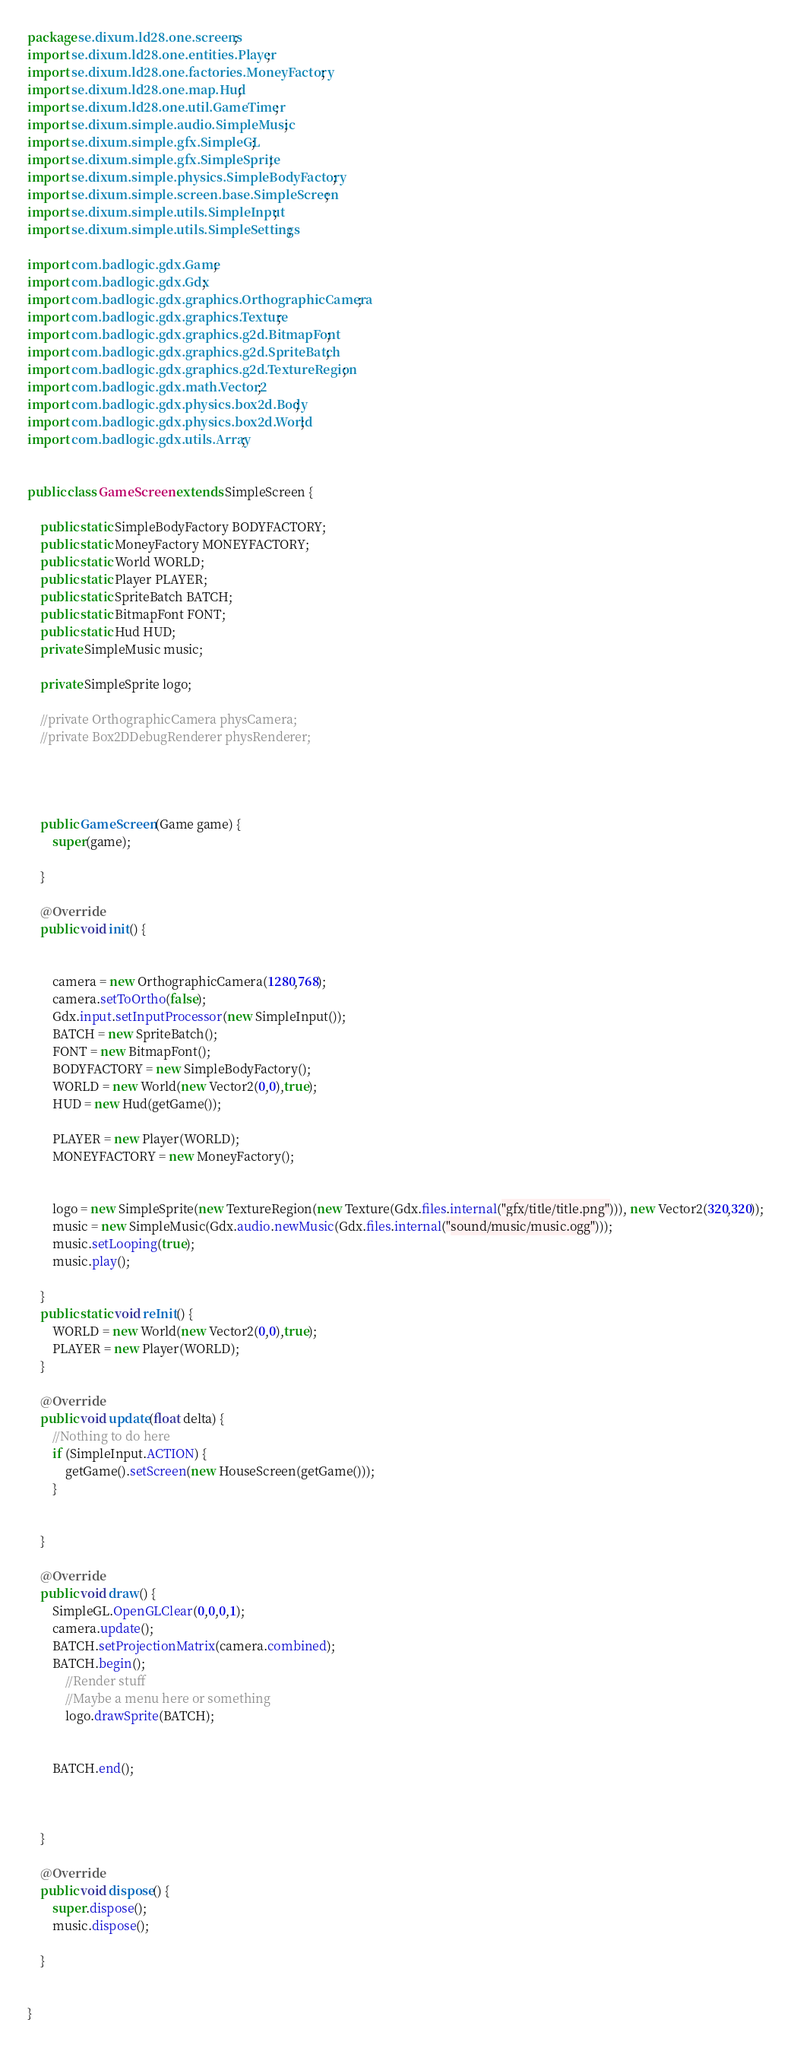Convert code to text. <code><loc_0><loc_0><loc_500><loc_500><_Java_>package se.dixum.ld28.one.screens;
import se.dixum.ld28.one.entities.Player;
import se.dixum.ld28.one.factories.MoneyFactory;
import se.dixum.ld28.one.map.Hud;
import se.dixum.ld28.one.util.GameTimer;
import se.dixum.simple.audio.SimpleMusic;
import se.dixum.simple.gfx.SimpleGL;
import se.dixum.simple.gfx.SimpleSprite;
import se.dixum.simple.physics.SimpleBodyFactory;
import se.dixum.simple.screen.base.SimpleScreen;
import se.dixum.simple.utils.SimpleInput;
import se.dixum.simple.utils.SimpleSettings;

import com.badlogic.gdx.Game;
import com.badlogic.gdx.Gdx;
import com.badlogic.gdx.graphics.OrthographicCamera;
import com.badlogic.gdx.graphics.Texture;
import com.badlogic.gdx.graphics.g2d.BitmapFont;
import com.badlogic.gdx.graphics.g2d.SpriteBatch;
import com.badlogic.gdx.graphics.g2d.TextureRegion;
import com.badlogic.gdx.math.Vector2;
import com.badlogic.gdx.physics.box2d.Body;
import com.badlogic.gdx.physics.box2d.World;
import com.badlogic.gdx.utils.Array;


public class GameScreen extends SimpleScreen {
	
	public static SimpleBodyFactory BODYFACTORY;
	public static MoneyFactory MONEYFACTORY;
	public static World WORLD;
	public static Player PLAYER;
	public static SpriteBatch BATCH;
	public static BitmapFont FONT;
	public static Hud HUD; 
	private SimpleMusic music;
	
	private SimpleSprite logo;
	
	//private OrthographicCamera physCamera;
	//private Box2DDebugRenderer physRenderer;



	
	public GameScreen(Game game) {
		super(game);

	}

	@Override
	public void init() {
		
		
		camera = new OrthographicCamera(1280,768);
		camera.setToOrtho(false);
		Gdx.input.setInputProcessor(new SimpleInput());
		BATCH = new SpriteBatch();
		FONT = new BitmapFont();
		BODYFACTORY = new SimpleBodyFactory();
		WORLD = new World(new Vector2(0,0),true);
		HUD = new Hud(getGame());
		
		PLAYER = new Player(WORLD);
		MONEYFACTORY = new MoneyFactory();
		
		
		logo = new SimpleSprite(new TextureRegion(new Texture(Gdx.files.internal("gfx/title/title.png"))), new Vector2(320,320));
		music = new SimpleMusic(Gdx.audio.newMusic(Gdx.files.internal("sound/music/music.ogg")));
		music.setLooping(true);
		music.play();

	}
	public static void reInit() {
		WORLD = new World(new Vector2(0,0),true);
		PLAYER = new Player(WORLD);
	}

	@Override
	public void update(float delta) {
		//Nothing to do here
		if (SimpleInput.ACTION) {
			getGame().setScreen(new HouseScreen(getGame()));
		}
		
		
	}

	@Override
	public void draw() {
		SimpleGL.OpenGLClear(0,0,0,1);
		camera.update();
		BATCH.setProjectionMatrix(camera.combined);
		BATCH.begin();
			//Render stuff
			//Maybe a menu here or something
			logo.drawSprite(BATCH);
			
		
		BATCH.end();
		
		
		
	}
	
	@Override
	public void dispose() {
		super.dispose();
		music.dispose();
		
	}


}
</code> 